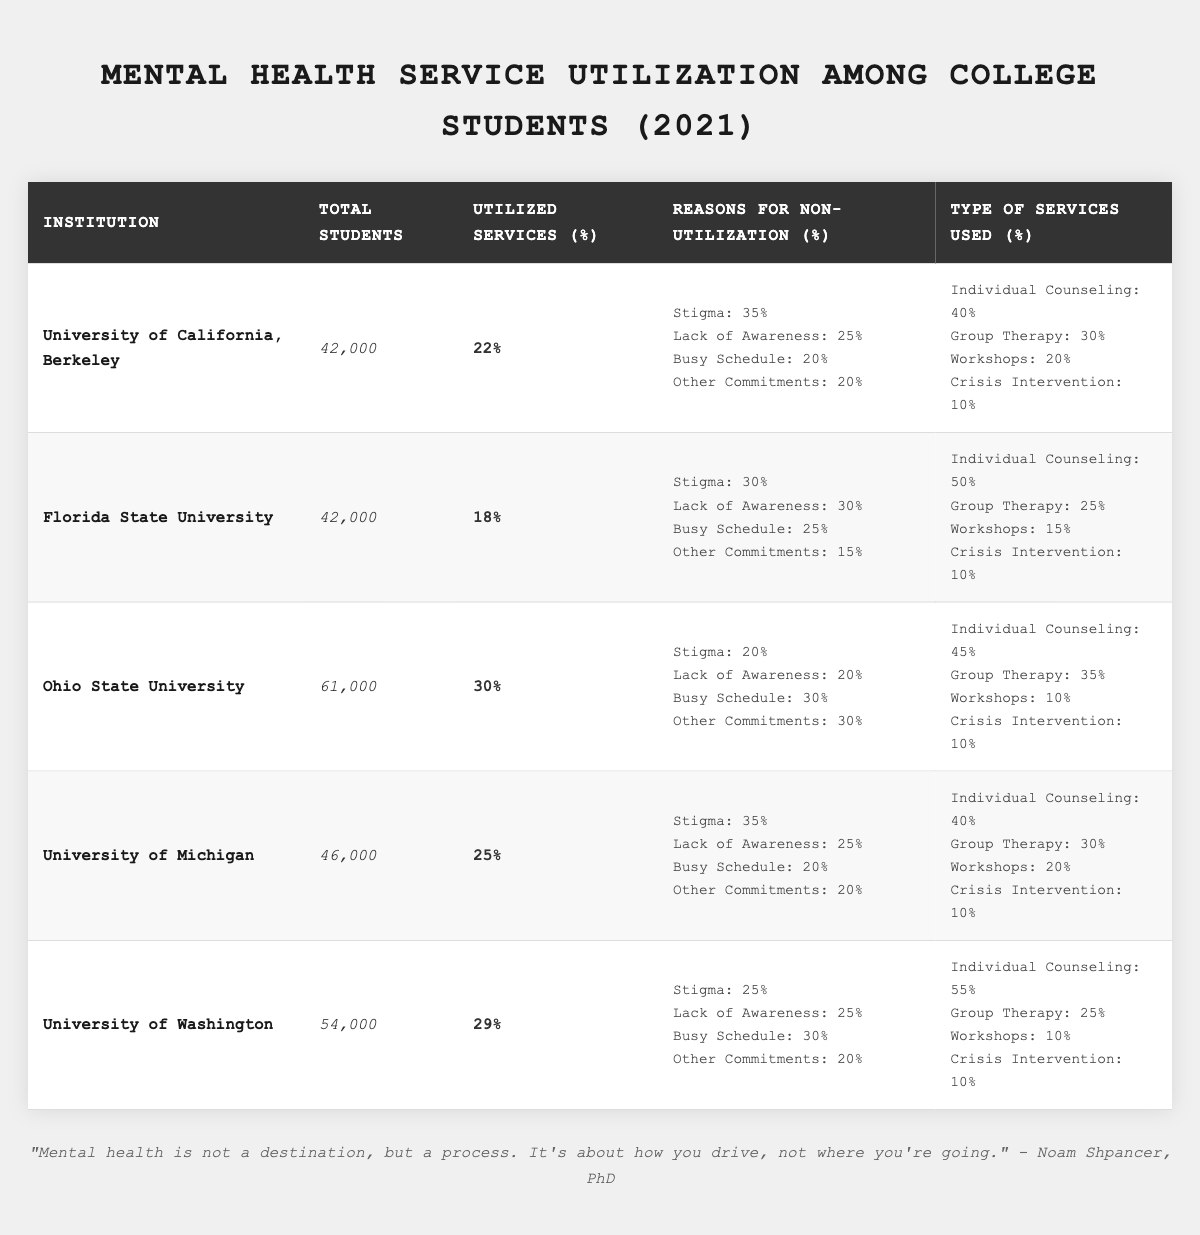What percentage of students utilized mental health services at Ohio State University? According to the table, the percentage of students who utilized services at Ohio State University is mentioned directly, which is 30%.
Answer: 30% Which institution had the highest percentage of service utilization? By comparing the percentages in the "Utilized Services (%)" column, Ohio State University has the highest utilization rate at 30%.
Answer: Ohio State University What is the total number of students at the University of Washington? The table specifies that the total number of students at the University of Washington is 54,000.
Answer: 54,000 How many universities had a utilization rate below 25%? Reviewing the "Utilized Services (%)" data, Florida State University (18%) and University of California, Berkeley (22%) had rates below 25%. Thus, there are two universities.
Answer: 2 What is the average percentage of students utilizing services across all institutions listed? The total percentage of utilization for the institutions is 22 + 18 + 30 + 25 + 29 = 124. Dividing by the five institutions gives an average of 124/5 = 24.8%.
Answer: 24.8% Which reason for non-utilization was most common at the University of California, Berkeley? Looking at the "Reasons for Non-Utilization (%)" section for UC Berkeley, the highest percentage is 35% for Stigma.
Answer: Stigma Is the percentage of students utilizing services at Florida State University greater than the percentage at the University of Michigan? The utilization percentage for Florida State University is 18%, and for the University of Michigan, it is 25%. Therefore, 18% is not greater than 25%.
Answer: No What percentage of services used at the University of Washington was for Individual Counseling? The "Type of Services Used (%)" for the University of Washington indicates that 55% of students used Individual Counseling.
Answer: 55% If we consider the top two institutions by utilization rates, what is the total number of students at those universities? Ohio State University (61,000) and University of Washington (54,000) are the top two. Adding their totals gives 61,000 + 54,000 = 115,000.
Answer: 115,000 What percentage of the reasons for non-utilization at Florida State University was due to a Busy Schedule? The table shows that 25% of students at Florida State University cited a Busy Schedule as a reason for non-utilization.
Answer: 25% 